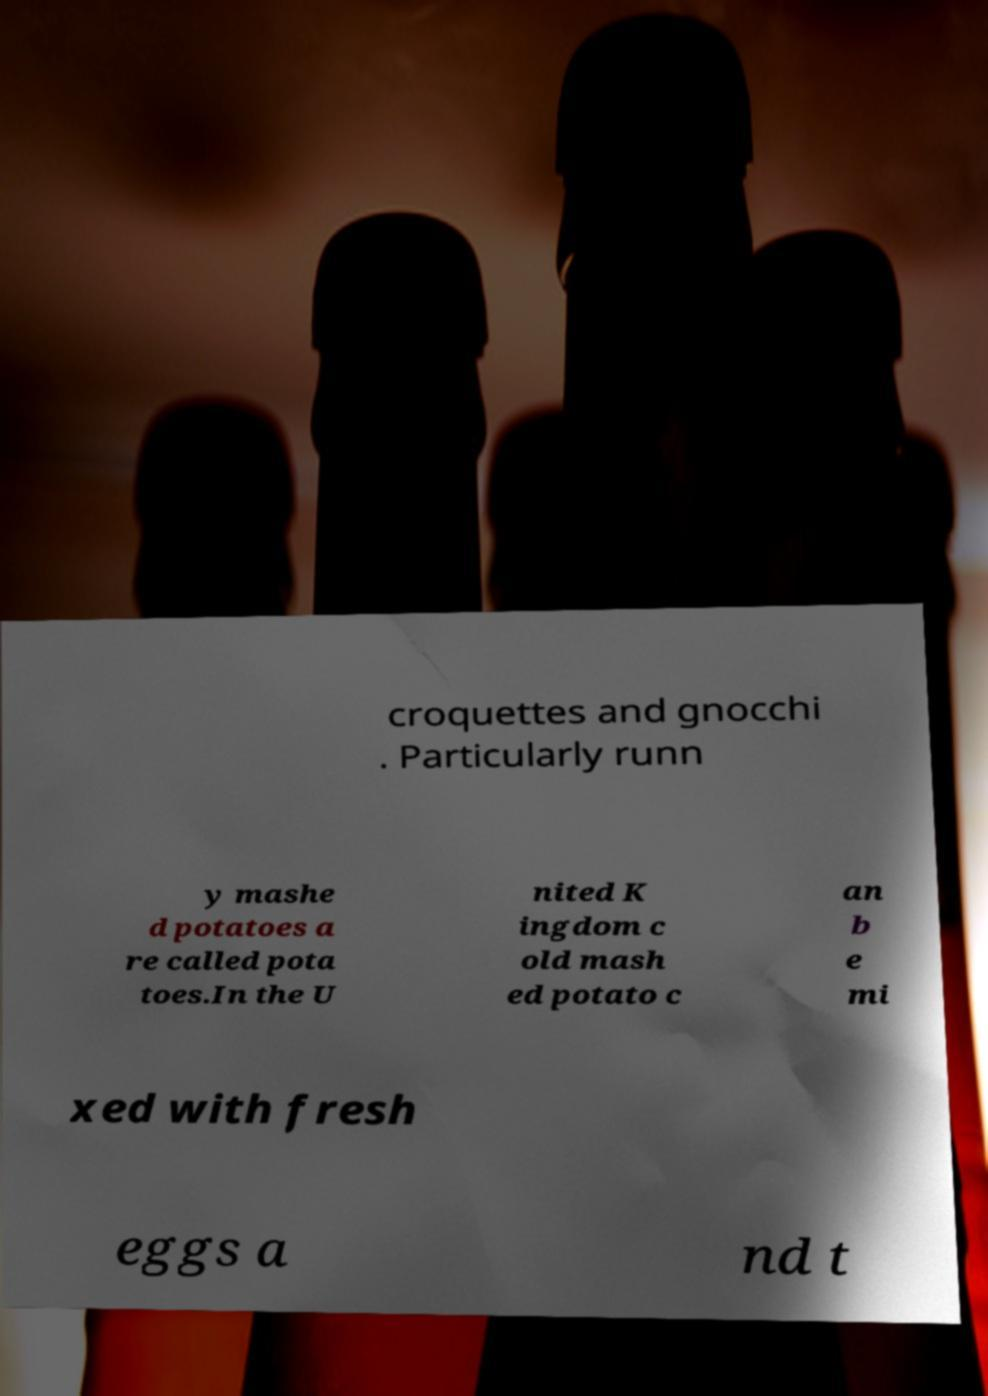Could you assist in decoding the text presented in this image and type it out clearly? croquettes and gnocchi . Particularly runn y mashe d potatoes a re called pota toes.In the U nited K ingdom c old mash ed potato c an b e mi xed with fresh eggs a nd t 